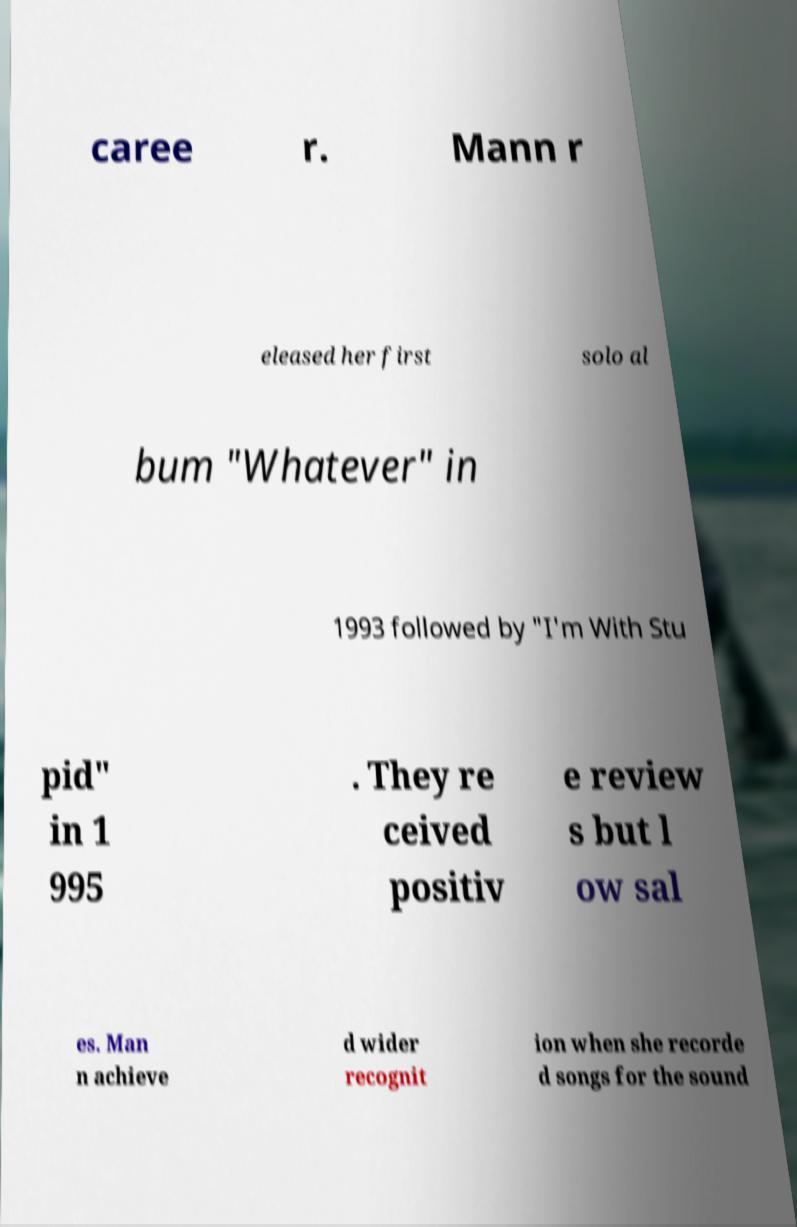Please read and relay the text visible in this image. What does it say? caree r. Mann r eleased her first solo al bum "Whatever" in 1993 followed by "I'm With Stu pid" in 1 995 . They re ceived positiv e review s but l ow sal es. Man n achieve d wider recognit ion when she recorde d songs for the sound 